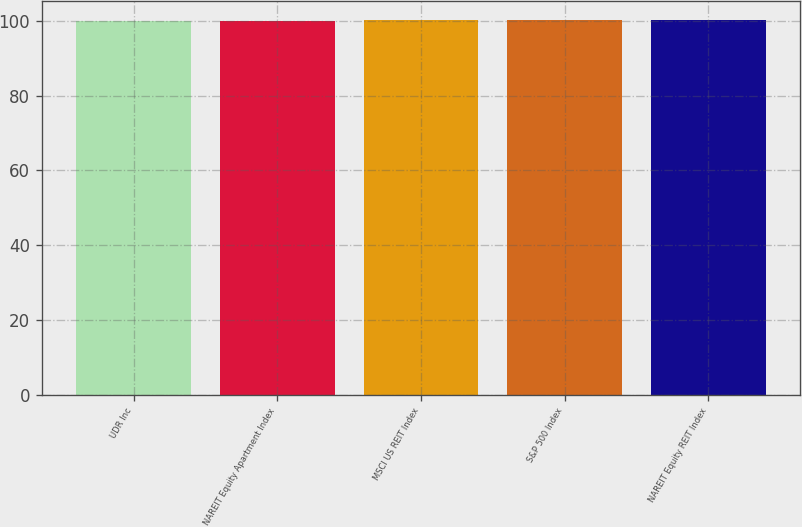Convert chart to OTSL. <chart><loc_0><loc_0><loc_500><loc_500><bar_chart><fcel>UDR Inc<fcel>NAREIT Equity Apartment Index<fcel>MSCI US REIT Index<fcel>S&P 500 Index<fcel>NAREIT Equity REIT Index<nl><fcel>100<fcel>100.1<fcel>100.2<fcel>100.3<fcel>100.4<nl></chart> 